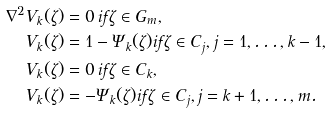<formula> <loc_0><loc_0><loc_500><loc_500>\nabla ^ { 2 } V _ { k } ( \zeta ) & = 0 \, i f \zeta \in G _ { m } , \\ V _ { k } ( \zeta ) & = 1 - \Psi _ { k } ( \zeta ) i f \zeta \in C _ { j } , j = 1 , \dots , k - 1 , \\ V _ { k } ( \zeta ) & = 0 \, i f \zeta \in C _ { k } , \\ V _ { k } ( \zeta ) & = - \Psi _ { k } ( \zeta ) i f \zeta \in C _ { j } , j = k + 1 , \dots , m .</formula> 